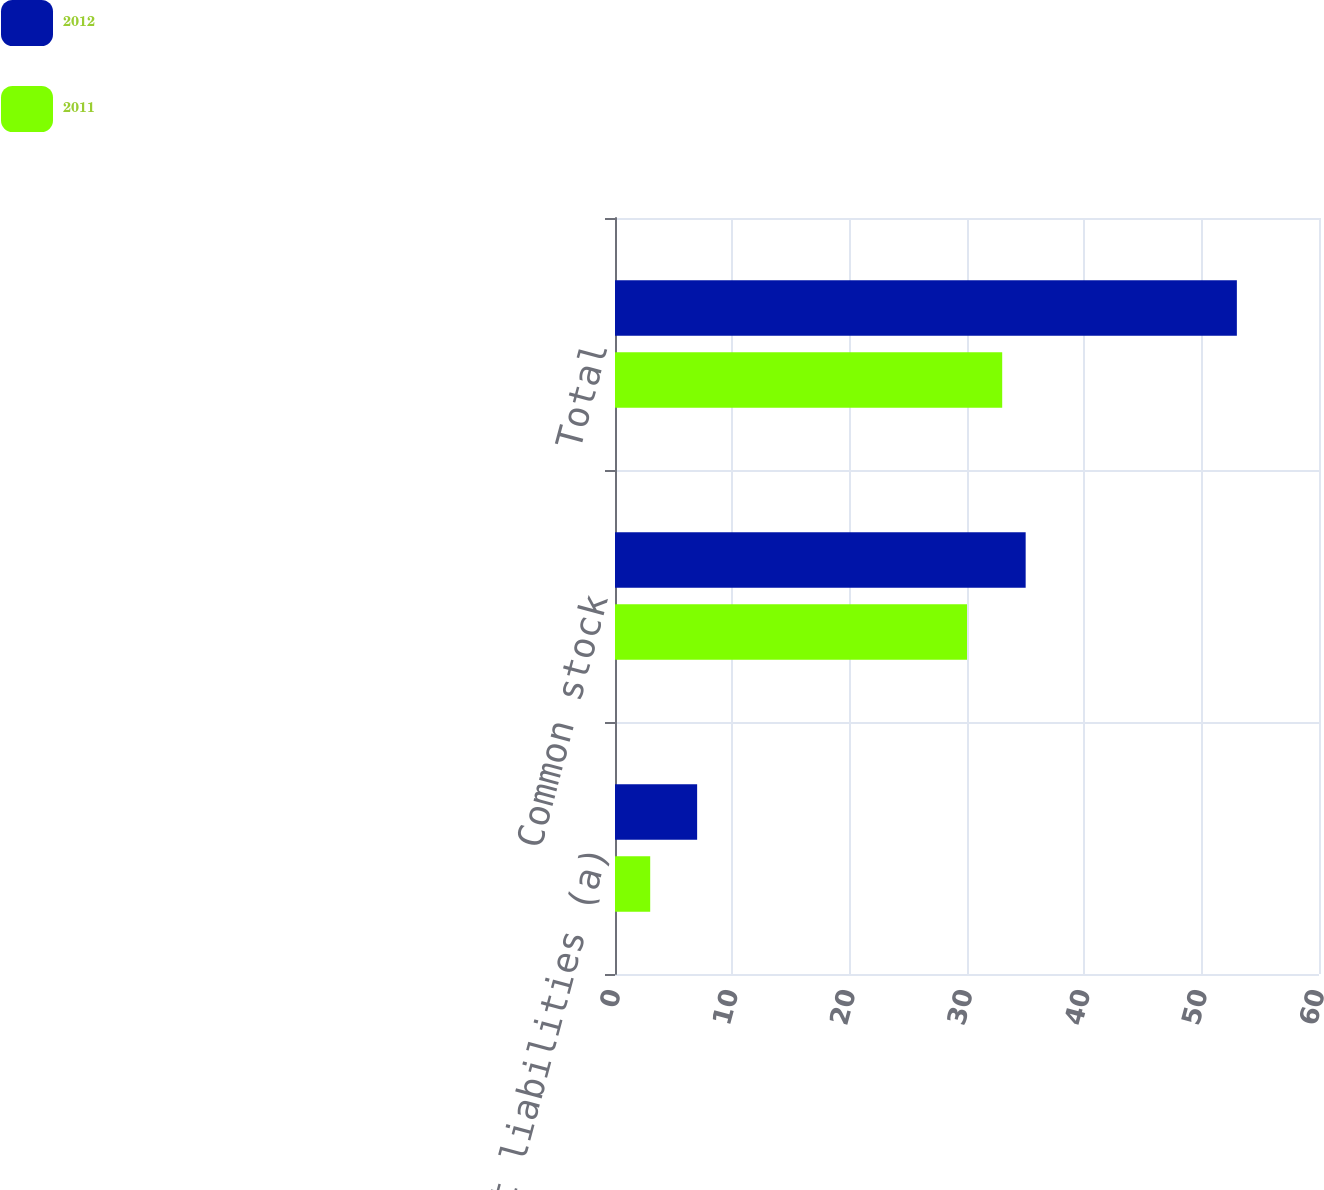<chart> <loc_0><loc_0><loc_500><loc_500><stacked_bar_chart><ecel><fcel>Current liabilities (a)<fcel>Common stock<fcel>Total<nl><fcel>2012<fcel>7<fcel>35<fcel>53<nl><fcel>2011<fcel>3<fcel>30<fcel>33<nl></chart> 